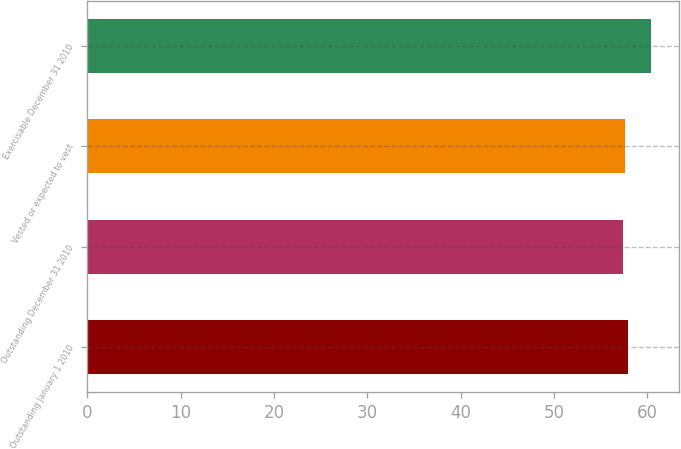Convert chart to OTSL. <chart><loc_0><loc_0><loc_500><loc_500><bar_chart><fcel>Outstanding January 1 2010<fcel>Outstanding December 31 2010<fcel>Vested or expected to vest<fcel>Exercisable December 31 2010<nl><fcel>57.99<fcel>57.37<fcel>57.68<fcel>60.44<nl></chart> 